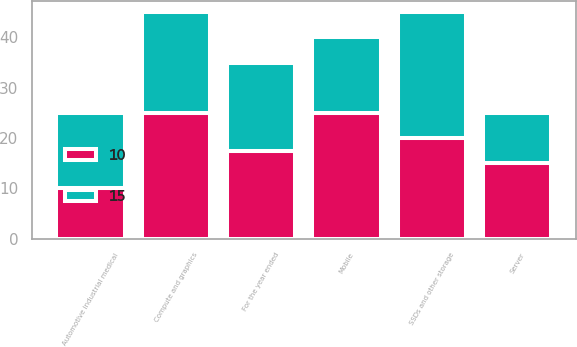<chart> <loc_0><loc_0><loc_500><loc_500><stacked_bar_chart><ecel><fcel>For the year ended<fcel>Compute and graphics<fcel>Mobile<fcel>SSDs and other storage<fcel>Server<fcel>Automotive industrial medical<nl><fcel>10<fcel>17.5<fcel>25<fcel>25<fcel>20<fcel>15<fcel>10<nl><fcel>15<fcel>17.5<fcel>20<fcel>15<fcel>25<fcel>10<fcel>15<nl></chart> 